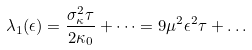Convert formula to latex. <formula><loc_0><loc_0><loc_500><loc_500>\lambda _ { 1 } ( \epsilon ) = \frac { \sigma ^ { 2 } _ { \kappa } \tau } { 2 \kappa _ { 0 } } + \dots = 9 \mu ^ { 2 } \epsilon ^ { 2 } \tau + \dots</formula> 